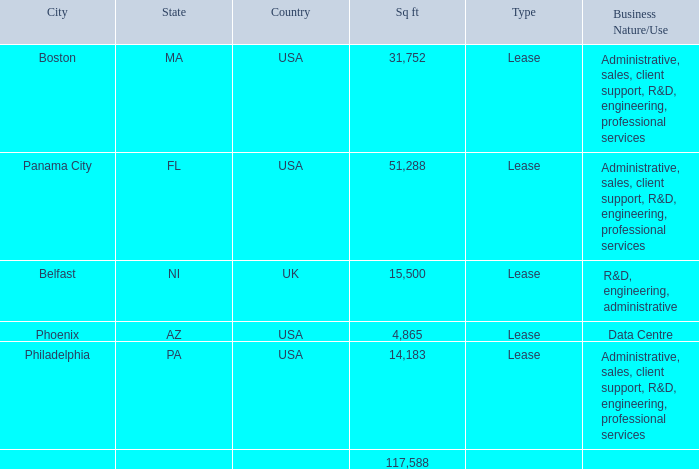Item 2. Properties
Our corporate headquarters are located in Culver City, California, where we occupy facilities totaling approximately 8,000 square feet on a monthto-month basis pursuant to a Shared Services Agreement with NantWorks. We use these facilities for administration, sales and marketing, research and development, engineering, client support, and professional services. In addition, we have 5 U.S. locations across four states and one international location. Our key facilities include the following:
United States
Boston, Massachusetts
Panama City, Florida
Philadelphia, Pennsylvania
Phoenix, Arizona
International
◦ Belfast, Northern Ireland
Note that on February 3, 2020, the Company completed the sale of its Connected Care business which includes the Panama City, Florida property.
We believe that our facilities are adequate to meet our needs in the near term, and that, if needed, suitable additional space will be available to accommodate any expansion of our operations.
The following table outlines our facilities location, square footage, and use:
Where is the company's corporate headquarters located? Culver city, california. What are the respective types of facilities in Boston and Panama City? Lease, lease. What are the respective square feet of the facilities located in Boston and Phoenix? 31,752, 4,865. What is the average square feet of the company's facilities in Boston and Panama City? (31,752 + 51,288)/2 
Answer: 41520. What is the average square feet of the company's facilities in Belfast and Phoenix? (15,500 + 4,865)/2 
Answer: 10182.5. What is the value of the company's facility in Phoenix as a percentage of the total square feet of all its facilities in the U.S.?
Answer scale should be: percent. 4,865/117,588 
Answer: 4.14. 